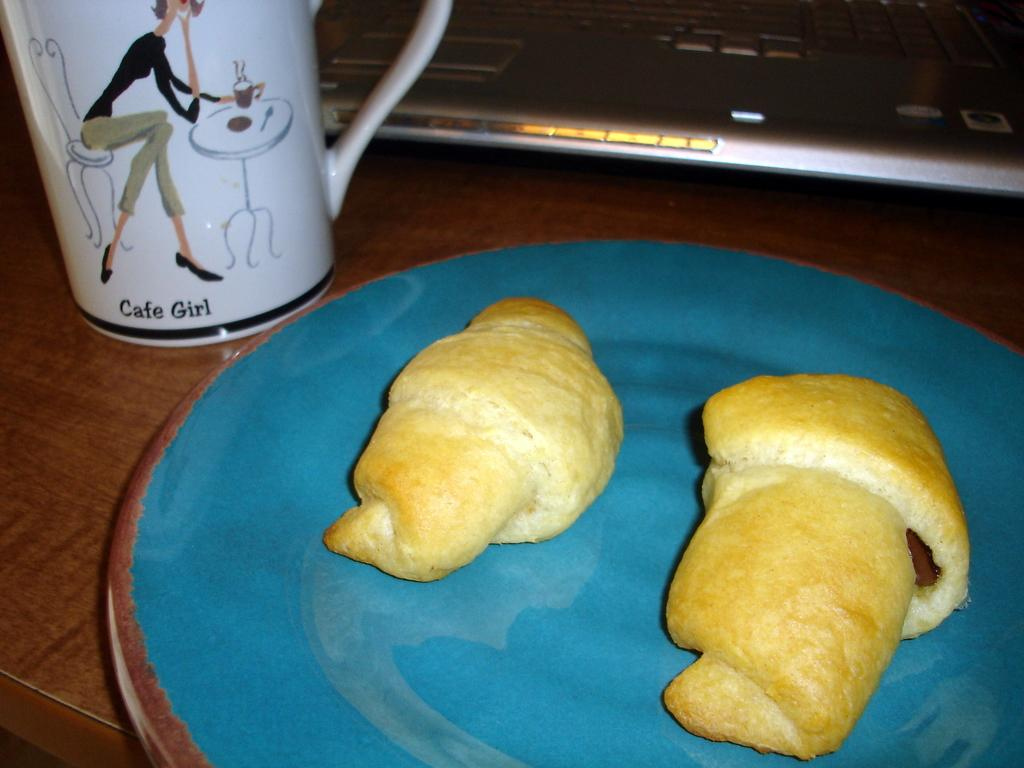What is the main subject in the center of the image? There is food on a plate in the center of the image. What electronic device is visible in the image? There is a laptop visible in the image. What type of container is on the left side of the image? There is a white cup on the left side of the image. What direction is the doll facing in the image? There is no doll present in the image. 